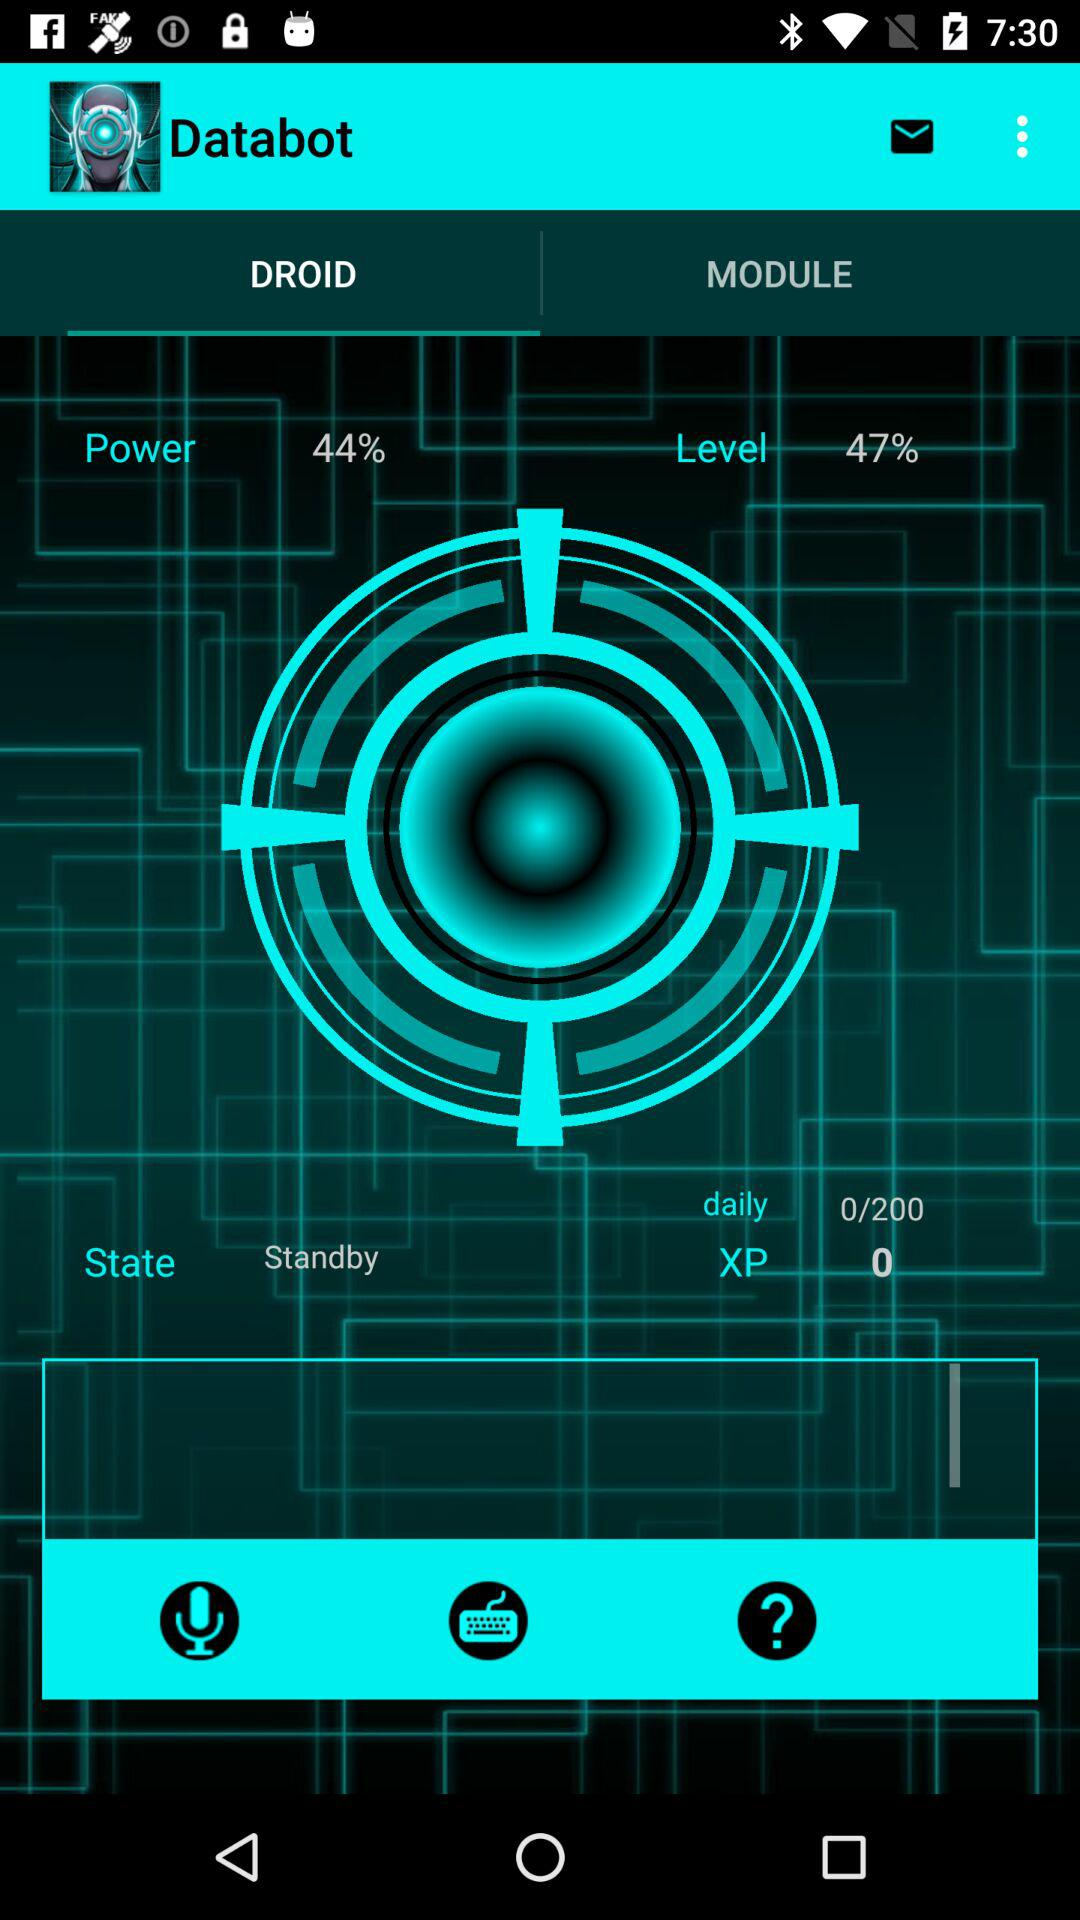What is the percentage of "Level"?
Answer the question using a single word or phrase. It is 47%. 